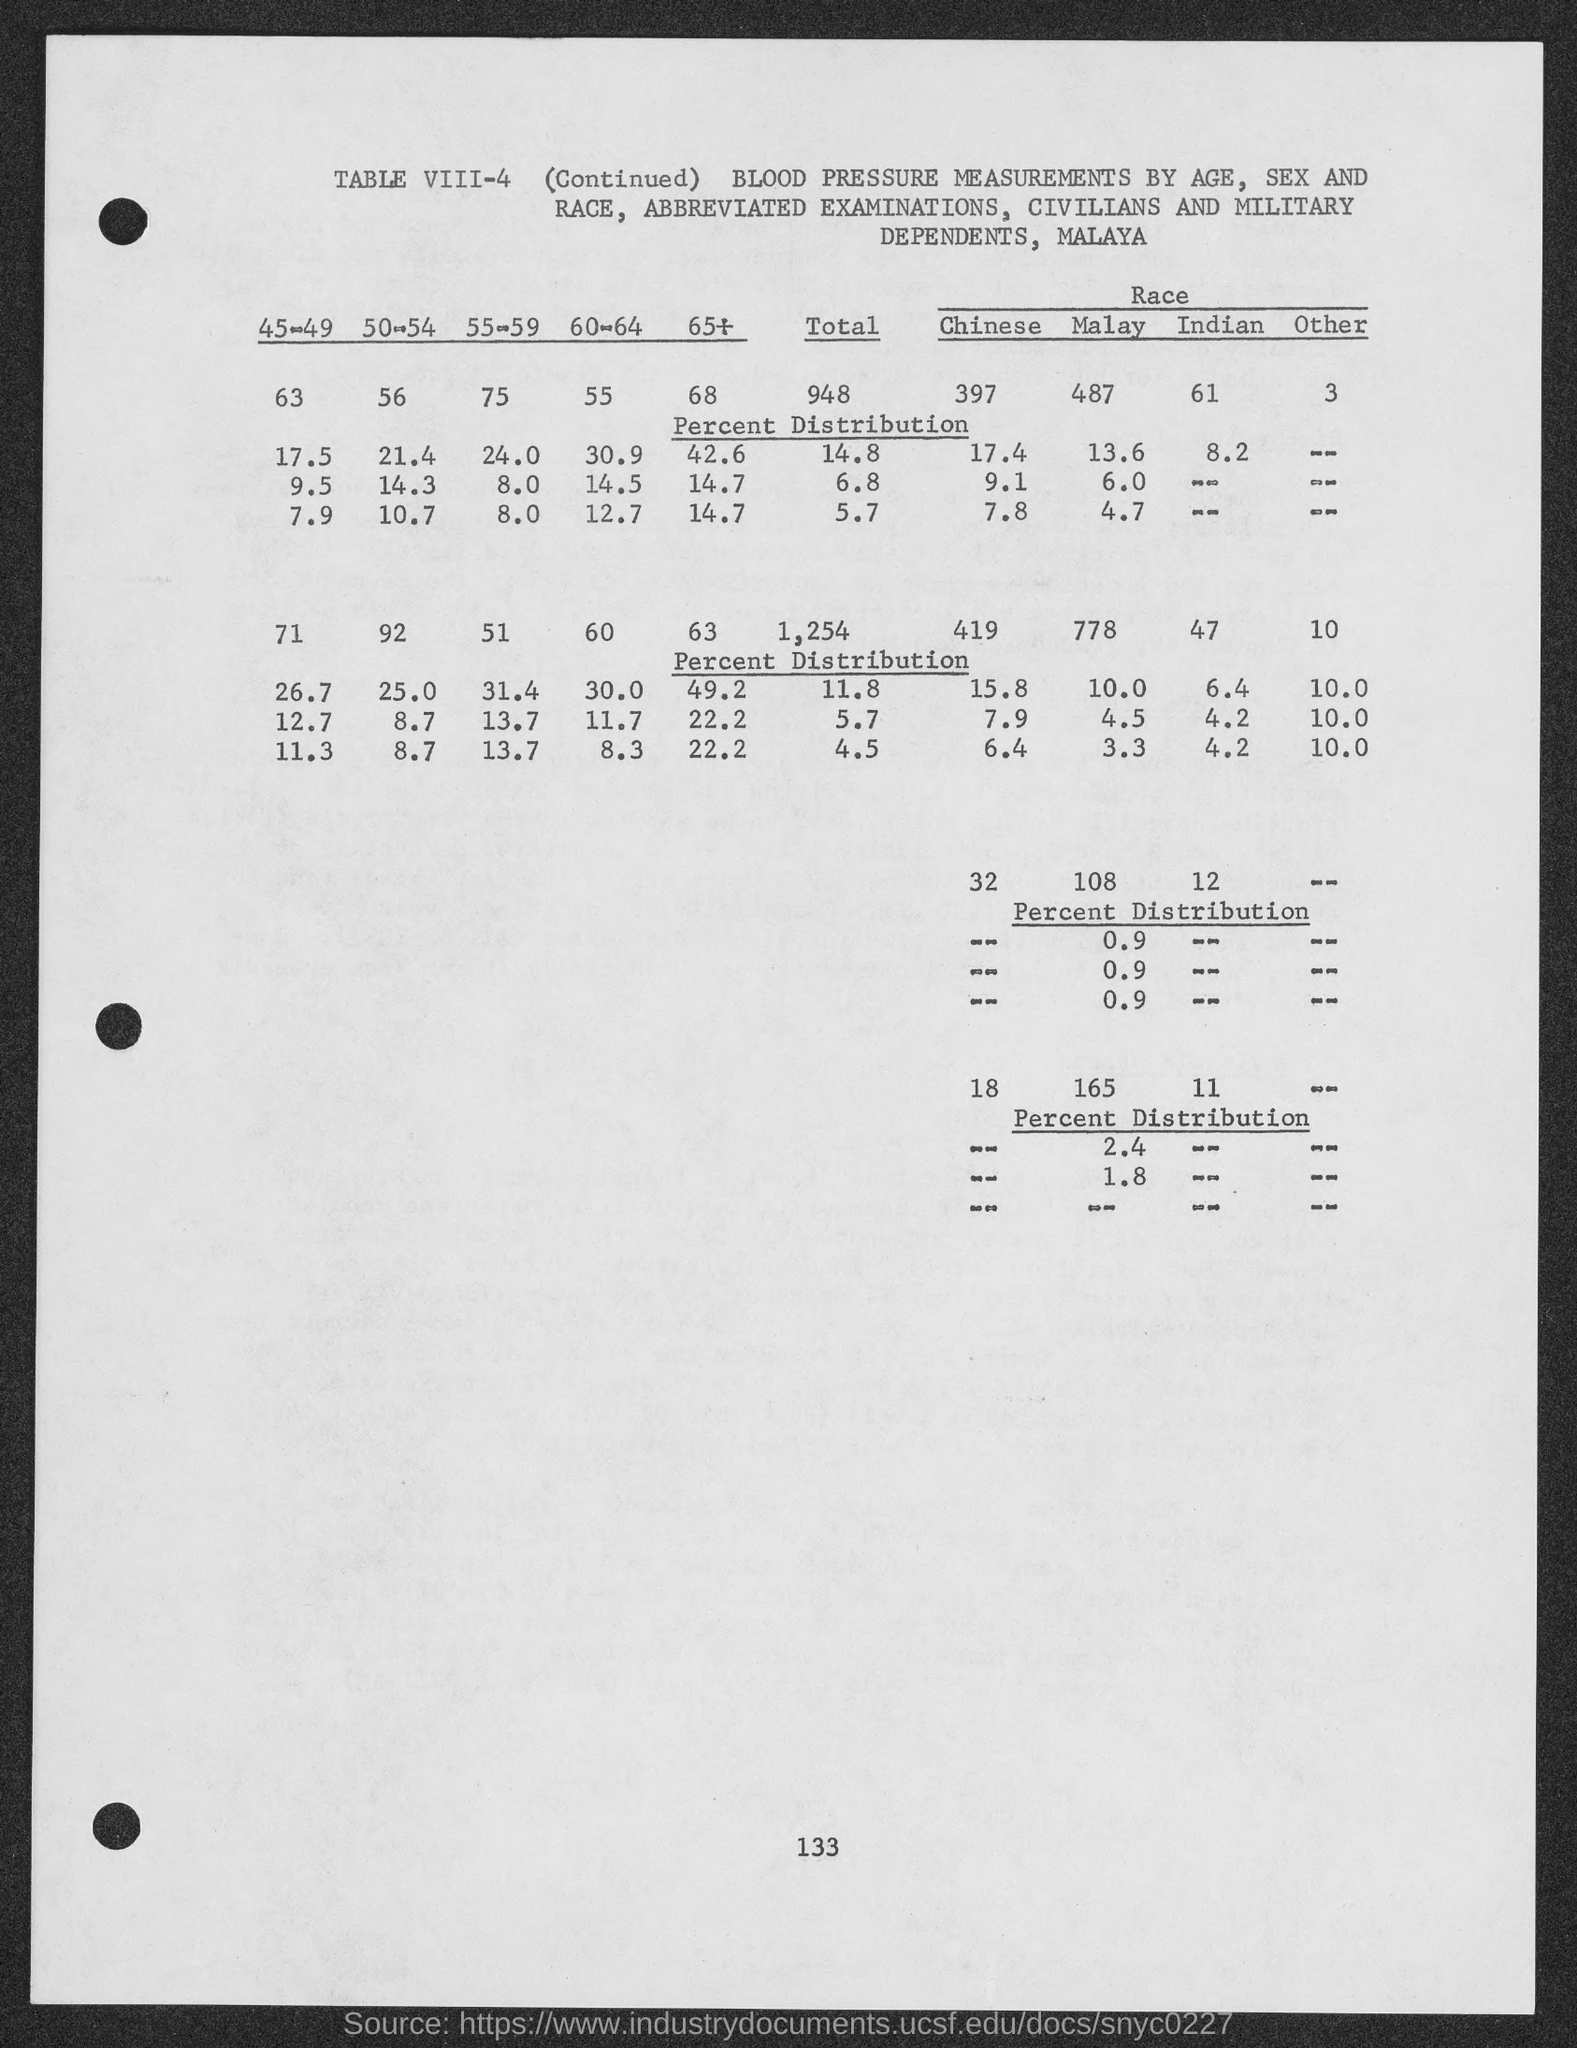What is the number at bottom of the page ?
Give a very brief answer. 133. What is the table no.?
Make the answer very short. Table VIII-4. 